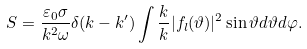Convert formula to latex. <formula><loc_0><loc_0><loc_500><loc_500>S = \frac { \varepsilon _ { 0 } \sigma } { k ^ { 2 } \omega } \delta ( k - k ^ { \prime } ) \int \frac { k } { k } | f _ { l } ( \vartheta ) | ^ { 2 } \sin \vartheta d \vartheta d \varphi .</formula> 